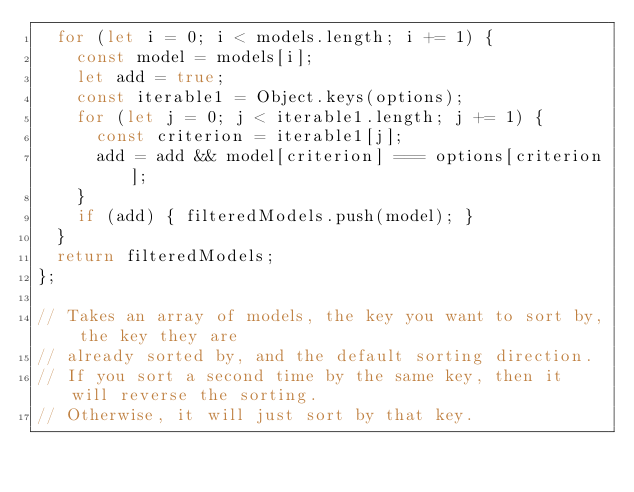<code> <loc_0><loc_0><loc_500><loc_500><_JavaScript_>  for (let i = 0; i < models.length; i += 1) {
    const model = models[i];
    let add = true;
    const iterable1 = Object.keys(options);
    for (let j = 0; j < iterable1.length; j += 1) {
      const criterion = iterable1[j];
      add = add && model[criterion] === options[criterion];
    }
    if (add) { filteredModels.push(model); }
  }
  return filteredModels;
};

// Takes an array of models, the key you want to sort by, the key they are
// already sorted by, and the default sorting direction.
// If you sort a second time by the same key, then it will reverse the sorting.
// Otherwise, it will just sort by that key.</code> 